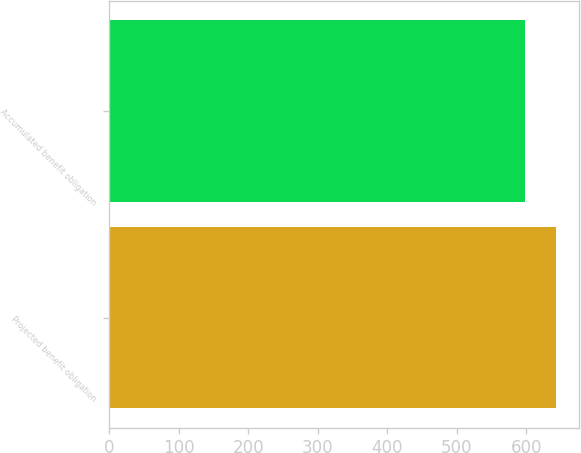Convert chart to OTSL. <chart><loc_0><loc_0><loc_500><loc_500><bar_chart><fcel>Projected benefit obligation<fcel>Accumulated benefit obligation<nl><fcel>643.5<fcel>598.4<nl></chart> 